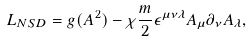Convert formula to latex. <formula><loc_0><loc_0><loc_500><loc_500>L _ { N S D } = g ( A ^ { 2 } ) - \chi \frac { m } { 2 } \epsilon ^ { \mu \nu \lambda } A _ { \mu } \partial _ { \nu } A _ { \lambda } ,</formula> 